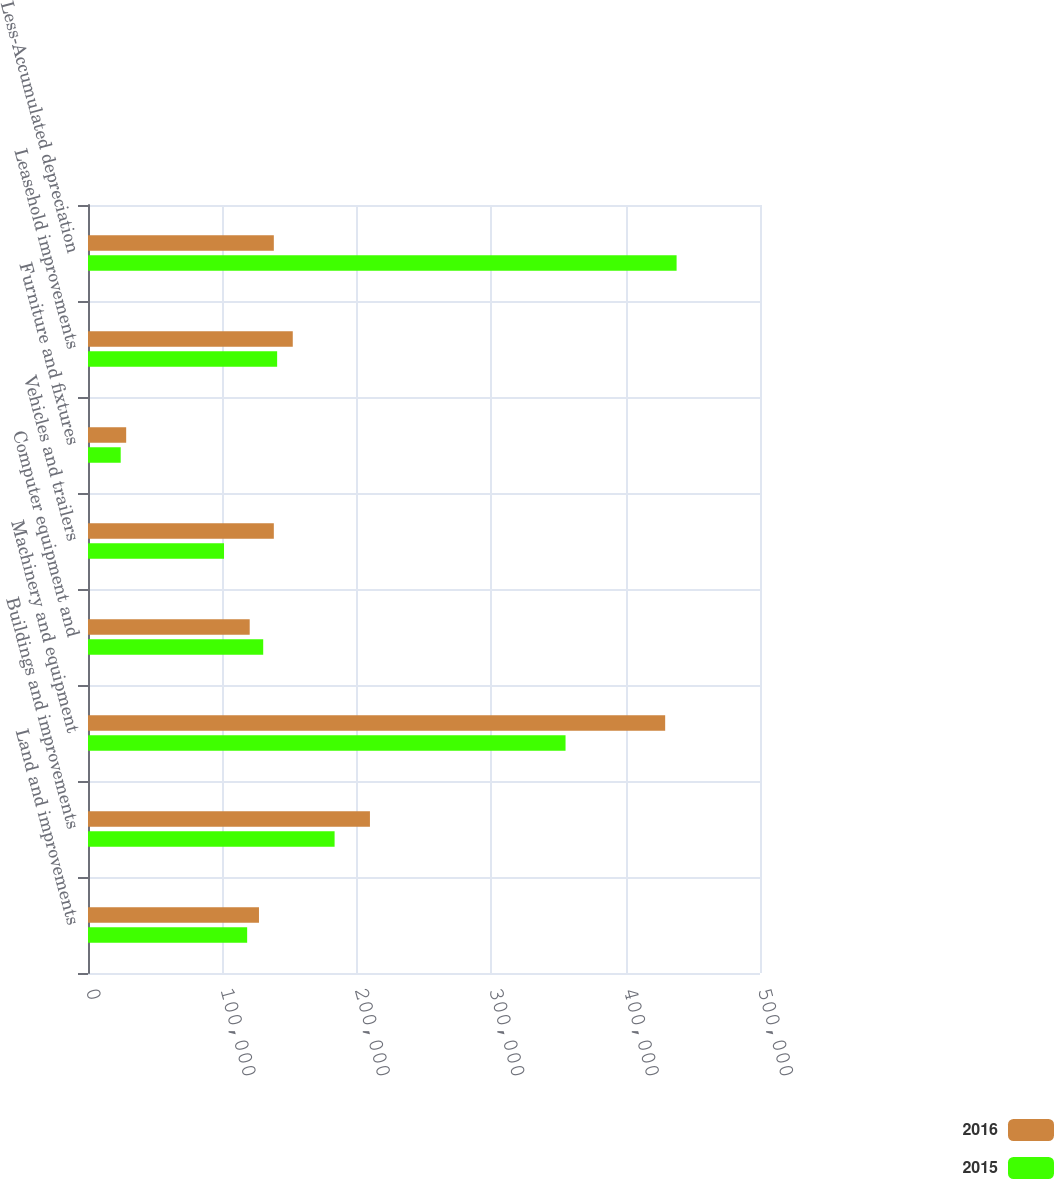Convert chart. <chart><loc_0><loc_0><loc_500><loc_500><stacked_bar_chart><ecel><fcel>Land and improvements<fcel>Buildings and improvements<fcel>Machinery and equipment<fcel>Computer equipment and<fcel>Vehicles and trailers<fcel>Furniture and fixtures<fcel>Leasehold improvements<fcel>Less-Accumulated depreciation<nl><fcel>2016<fcel>127211<fcel>209773<fcel>429446<fcel>120316<fcel>138263<fcel>28405<fcel>152356<fcel>138263<nl><fcel>2015<fcel>118420<fcel>183480<fcel>355313<fcel>130363<fcel>101201<fcel>24332<fcel>140732<fcel>437946<nl></chart> 